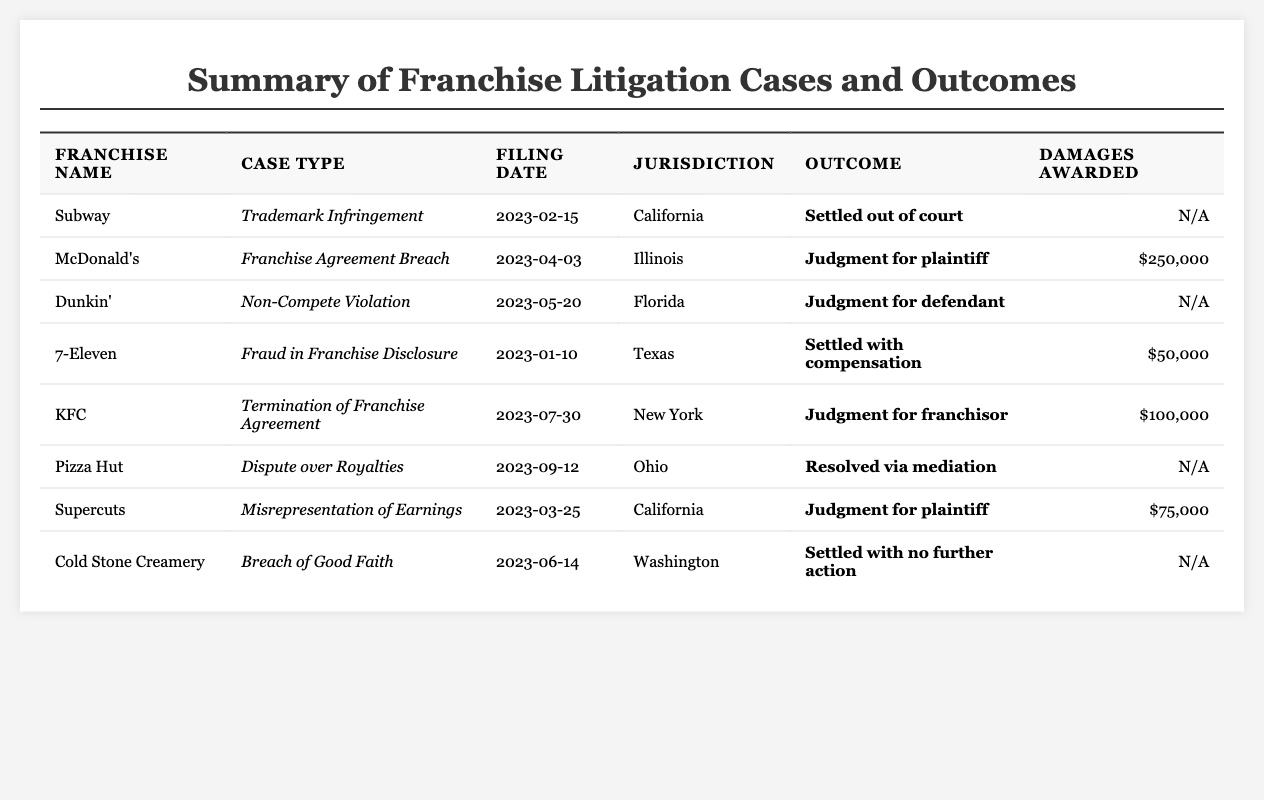What franchise faced a trademark infringement case? The table lists franchise litigation cases. Looking for the case type "Trademark Infringement" leads us to the entry for Subway.
Answer: Subway Which case awarded $250,000 in damages? The table shows each case and their respective outcomes. McDonald's is listed with a judgment for the plaintiff, awarding $250,000.
Answer: McDonald's How many cases had outcomes in favor of the defendant? By reviewing the outcomes in the table, we see that Dunkin' had a judgment for the defendant. So, there is 1 case favoring the defendant.
Answer: 1 What was the filing date of the case involving KFC? The KFC case is listed in the table, and by checking the "Filing Date" column, we find it was filed on July 30, 2023.
Answer: July 30, 2023 Which franchise had the highest damages awarded? We analyze the damages awarded in the table. McDonald's ($250,000) has the highest amount, followed by KFC ($100,000) and Supercuts ($75,000).
Answer: McDonald's In which jurisdiction did the fraud case occur? The table indicates that the franchise case for fraud in franchise disclosure occurred in Texas as noted in the jurisdiction column.
Answer: Texas Is there any case that ended with no damages awarded? Reviewing the damages awarded in the table, both Dunkin' and Cold Stone Creamery had outcomes with "N/A" indicating no damages awarded.
Answer: Yes What outcome was reached for the Pizza Hut royalties dispute? The table specifies that the outcome for the Pizza Hut case was "Resolved via mediation.”
Answer: Resolved via mediation How many franchises had their cases settled without further action? The table lists Cold Stone Creamery as settled with no further action. By observation, it appears that only one case falls under this category.
Answer: 1 What fraction of cases resulted in a judgment for the plaintiff? There are 4 cases (McDonald's, Supercuts, Subway, and KFC) that resulted in judgments for the plaintiff from a total of 8 cases. Therefore, the fraction is 4/8 which simplifies to 1/2.
Answer: 1/2 